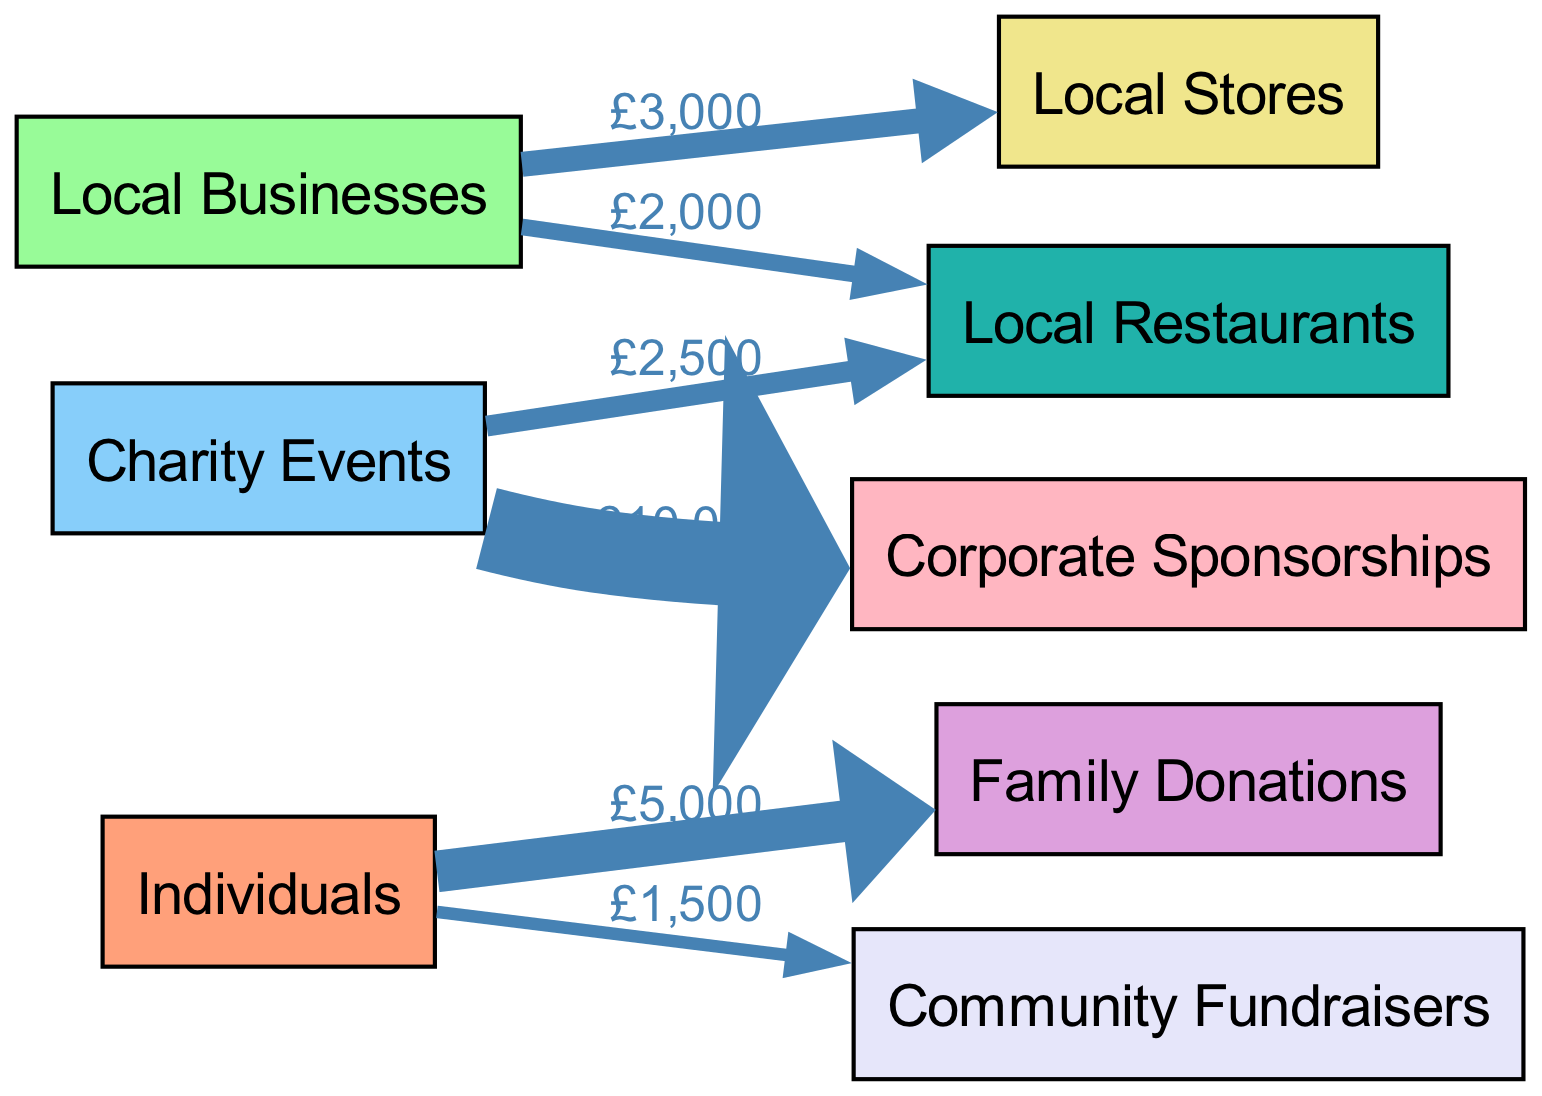What is the total amount donated by individuals? The diagram shows that individuals donated a total of £6,500, which includes £5,000 in family donations and £1,500 in community fundraisers. To find the total, we simply add these two amounts.
Answer: 6500 Which local business received the highest donation amount? In the diagram, local businesses are shown contributing £3,000 to local stores and £2,000 to local restaurants. Since £3,000 is greater than £2,000, local stores received the highest donation.
Answer: Local Stores How many different donor categories are represented in the diagram? The diagram includes three main donor categories: Individuals, Local Businesses, and Charity Events. We count the number of unique donor categories, which amounts to three.
Answer: 3 What is the total amount raised from charity events? The diagram displays donations received from charity events including £2,500 to local restaurants and £10,000 to corporate sponsorships. To find the total, we add these two contributions together, resulting in £12,500.
Answer: 12500 Which category has the least total amount in the donations? By examining the flow of donations, we see that community fundraisers received £1,500, which is less than the donations received by family donations, local stores, and local restaurants. Therefore, community fundraisers represent the least amount in the donations.
Answer: Community Fundraisers How much money was contributed by local businesses? According to the diagram, local businesses donated a total of £5,000, with £3,000 allocated to local stores and £2,000 to local restaurants. To find the total contribution, we sum these two amounts.
Answer: 5000 What is the value of corporate sponsorships received from charity events? The diagram illustrates a direct flow of £10,000 from charity events to corporate sponsorships. Thus, the value of corporate sponsorships received is clearly indicated as £10,000.
Answer: 10000 Which type of donor contributed the least amount overall? Assessing the contributions, community fundraisers had only £1,500, which is the smallest amount when compared to the contributions by individuals (£6,500), local businesses (£5,000), and charity events (£12,500).
Answer: Community Fundraisers 